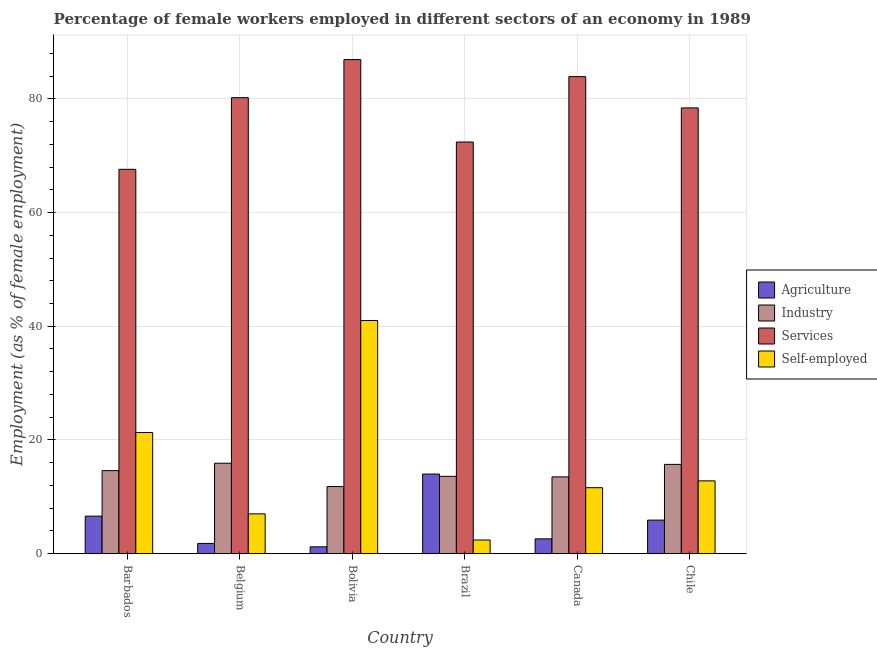How many different coloured bars are there?
Offer a terse response. 4. How many groups of bars are there?
Keep it short and to the point. 6. How many bars are there on the 1st tick from the right?
Offer a very short reply. 4. What is the percentage of female workers in industry in Brazil?
Offer a terse response. 13.6. Across all countries, what is the maximum percentage of female workers in services?
Give a very brief answer. 86.9. Across all countries, what is the minimum percentage of female workers in industry?
Your answer should be compact. 11.8. In which country was the percentage of self employed female workers minimum?
Provide a short and direct response. Brazil. What is the total percentage of self employed female workers in the graph?
Ensure brevity in your answer.  96.1. What is the difference between the percentage of female workers in agriculture in Barbados and that in Chile?
Provide a succinct answer. 0.7. What is the difference between the percentage of female workers in agriculture in Canada and the percentage of self employed female workers in Barbados?
Make the answer very short. -18.7. What is the average percentage of female workers in industry per country?
Give a very brief answer. 14.18. What is the difference between the percentage of female workers in services and percentage of female workers in industry in Chile?
Offer a very short reply. 62.7. What is the ratio of the percentage of female workers in industry in Bolivia to that in Brazil?
Your response must be concise. 0.87. Is the percentage of female workers in services in Belgium less than that in Canada?
Make the answer very short. Yes. Is the difference between the percentage of female workers in services in Belgium and Bolivia greater than the difference between the percentage of self employed female workers in Belgium and Bolivia?
Ensure brevity in your answer.  Yes. What is the difference between the highest and the second highest percentage of female workers in industry?
Your answer should be very brief. 0.2. What is the difference between the highest and the lowest percentage of self employed female workers?
Provide a succinct answer. 38.6. Is it the case that in every country, the sum of the percentage of female workers in services and percentage of female workers in industry is greater than the sum of percentage of female workers in agriculture and percentage of self employed female workers?
Keep it short and to the point. Yes. What does the 2nd bar from the left in Bolivia represents?
Give a very brief answer. Industry. What does the 4th bar from the right in Bolivia represents?
Offer a terse response. Agriculture. Is it the case that in every country, the sum of the percentage of female workers in agriculture and percentage of female workers in industry is greater than the percentage of female workers in services?
Your answer should be very brief. No. What is the difference between two consecutive major ticks on the Y-axis?
Ensure brevity in your answer.  20. Are the values on the major ticks of Y-axis written in scientific E-notation?
Your answer should be compact. No. Does the graph contain any zero values?
Ensure brevity in your answer.  No. Does the graph contain grids?
Ensure brevity in your answer.  Yes. What is the title of the graph?
Your answer should be very brief. Percentage of female workers employed in different sectors of an economy in 1989. Does "Italy" appear as one of the legend labels in the graph?
Your response must be concise. No. What is the label or title of the Y-axis?
Your answer should be compact. Employment (as % of female employment). What is the Employment (as % of female employment) of Agriculture in Barbados?
Keep it short and to the point. 6.6. What is the Employment (as % of female employment) of Industry in Barbados?
Your answer should be very brief. 14.6. What is the Employment (as % of female employment) in Services in Barbados?
Keep it short and to the point. 67.6. What is the Employment (as % of female employment) of Self-employed in Barbados?
Provide a succinct answer. 21.3. What is the Employment (as % of female employment) in Agriculture in Belgium?
Ensure brevity in your answer.  1.8. What is the Employment (as % of female employment) of Industry in Belgium?
Make the answer very short. 15.9. What is the Employment (as % of female employment) of Services in Belgium?
Give a very brief answer. 80.2. What is the Employment (as % of female employment) of Self-employed in Belgium?
Keep it short and to the point. 7. What is the Employment (as % of female employment) of Agriculture in Bolivia?
Your answer should be compact. 1.2. What is the Employment (as % of female employment) in Industry in Bolivia?
Your answer should be compact. 11.8. What is the Employment (as % of female employment) of Services in Bolivia?
Your answer should be compact. 86.9. What is the Employment (as % of female employment) of Industry in Brazil?
Provide a succinct answer. 13.6. What is the Employment (as % of female employment) of Services in Brazil?
Offer a terse response. 72.4. What is the Employment (as % of female employment) in Self-employed in Brazil?
Offer a terse response. 2.4. What is the Employment (as % of female employment) in Agriculture in Canada?
Offer a terse response. 2.6. What is the Employment (as % of female employment) of Industry in Canada?
Your response must be concise. 13.5. What is the Employment (as % of female employment) in Services in Canada?
Provide a short and direct response. 83.9. What is the Employment (as % of female employment) in Self-employed in Canada?
Give a very brief answer. 11.6. What is the Employment (as % of female employment) of Agriculture in Chile?
Provide a succinct answer. 5.9. What is the Employment (as % of female employment) of Industry in Chile?
Make the answer very short. 15.7. What is the Employment (as % of female employment) in Services in Chile?
Keep it short and to the point. 78.4. What is the Employment (as % of female employment) of Self-employed in Chile?
Provide a short and direct response. 12.8. Across all countries, what is the maximum Employment (as % of female employment) of Industry?
Provide a short and direct response. 15.9. Across all countries, what is the maximum Employment (as % of female employment) in Services?
Keep it short and to the point. 86.9. Across all countries, what is the minimum Employment (as % of female employment) of Agriculture?
Ensure brevity in your answer.  1.2. Across all countries, what is the minimum Employment (as % of female employment) in Industry?
Provide a short and direct response. 11.8. Across all countries, what is the minimum Employment (as % of female employment) of Services?
Give a very brief answer. 67.6. Across all countries, what is the minimum Employment (as % of female employment) in Self-employed?
Your response must be concise. 2.4. What is the total Employment (as % of female employment) in Agriculture in the graph?
Provide a short and direct response. 32.1. What is the total Employment (as % of female employment) of Industry in the graph?
Give a very brief answer. 85.1. What is the total Employment (as % of female employment) of Services in the graph?
Make the answer very short. 469.4. What is the total Employment (as % of female employment) in Self-employed in the graph?
Provide a short and direct response. 96.1. What is the difference between the Employment (as % of female employment) in Agriculture in Barbados and that in Belgium?
Offer a very short reply. 4.8. What is the difference between the Employment (as % of female employment) of Services in Barbados and that in Bolivia?
Provide a short and direct response. -19.3. What is the difference between the Employment (as % of female employment) of Self-employed in Barbados and that in Bolivia?
Your answer should be compact. -19.7. What is the difference between the Employment (as % of female employment) in Services in Barbados and that in Canada?
Offer a very short reply. -16.3. What is the difference between the Employment (as % of female employment) in Industry in Belgium and that in Bolivia?
Your answer should be very brief. 4.1. What is the difference between the Employment (as % of female employment) of Self-employed in Belgium and that in Bolivia?
Offer a terse response. -34. What is the difference between the Employment (as % of female employment) in Industry in Belgium and that in Canada?
Provide a succinct answer. 2.4. What is the difference between the Employment (as % of female employment) of Services in Belgium and that in Canada?
Provide a short and direct response. -3.7. What is the difference between the Employment (as % of female employment) in Agriculture in Belgium and that in Chile?
Offer a very short reply. -4.1. What is the difference between the Employment (as % of female employment) of Industry in Belgium and that in Chile?
Your answer should be very brief. 0.2. What is the difference between the Employment (as % of female employment) in Services in Belgium and that in Chile?
Offer a very short reply. 1.8. What is the difference between the Employment (as % of female employment) of Agriculture in Bolivia and that in Brazil?
Offer a very short reply. -12.8. What is the difference between the Employment (as % of female employment) of Industry in Bolivia and that in Brazil?
Give a very brief answer. -1.8. What is the difference between the Employment (as % of female employment) in Self-employed in Bolivia and that in Brazil?
Provide a succinct answer. 38.6. What is the difference between the Employment (as % of female employment) in Self-employed in Bolivia and that in Canada?
Offer a very short reply. 29.4. What is the difference between the Employment (as % of female employment) in Agriculture in Bolivia and that in Chile?
Make the answer very short. -4.7. What is the difference between the Employment (as % of female employment) of Industry in Bolivia and that in Chile?
Ensure brevity in your answer.  -3.9. What is the difference between the Employment (as % of female employment) in Services in Bolivia and that in Chile?
Ensure brevity in your answer.  8.5. What is the difference between the Employment (as % of female employment) in Self-employed in Bolivia and that in Chile?
Make the answer very short. 28.2. What is the difference between the Employment (as % of female employment) in Agriculture in Brazil and that in Canada?
Your response must be concise. 11.4. What is the difference between the Employment (as % of female employment) in Services in Brazil and that in Canada?
Keep it short and to the point. -11.5. What is the difference between the Employment (as % of female employment) in Services in Brazil and that in Chile?
Keep it short and to the point. -6. What is the difference between the Employment (as % of female employment) of Services in Canada and that in Chile?
Offer a very short reply. 5.5. What is the difference between the Employment (as % of female employment) in Agriculture in Barbados and the Employment (as % of female employment) in Industry in Belgium?
Your answer should be very brief. -9.3. What is the difference between the Employment (as % of female employment) of Agriculture in Barbados and the Employment (as % of female employment) of Services in Belgium?
Keep it short and to the point. -73.6. What is the difference between the Employment (as % of female employment) of Industry in Barbados and the Employment (as % of female employment) of Services in Belgium?
Offer a very short reply. -65.6. What is the difference between the Employment (as % of female employment) in Services in Barbados and the Employment (as % of female employment) in Self-employed in Belgium?
Keep it short and to the point. 60.6. What is the difference between the Employment (as % of female employment) of Agriculture in Barbados and the Employment (as % of female employment) of Industry in Bolivia?
Provide a short and direct response. -5.2. What is the difference between the Employment (as % of female employment) of Agriculture in Barbados and the Employment (as % of female employment) of Services in Bolivia?
Provide a short and direct response. -80.3. What is the difference between the Employment (as % of female employment) of Agriculture in Barbados and the Employment (as % of female employment) of Self-employed in Bolivia?
Your response must be concise. -34.4. What is the difference between the Employment (as % of female employment) in Industry in Barbados and the Employment (as % of female employment) in Services in Bolivia?
Keep it short and to the point. -72.3. What is the difference between the Employment (as % of female employment) of Industry in Barbados and the Employment (as % of female employment) of Self-employed in Bolivia?
Ensure brevity in your answer.  -26.4. What is the difference between the Employment (as % of female employment) of Services in Barbados and the Employment (as % of female employment) of Self-employed in Bolivia?
Offer a very short reply. 26.6. What is the difference between the Employment (as % of female employment) in Agriculture in Barbados and the Employment (as % of female employment) in Industry in Brazil?
Make the answer very short. -7. What is the difference between the Employment (as % of female employment) in Agriculture in Barbados and the Employment (as % of female employment) in Services in Brazil?
Keep it short and to the point. -65.8. What is the difference between the Employment (as % of female employment) in Agriculture in Barbados and the Employment (as % of female employment) in Self-employed in Brazil?
Offer a terse response. 4.2. What is the difference between the Employment (as % of female employment) in Industry in Barbados and the Employment (as % of female employment) in Services in Brazil?
Offer a terse response. -57.8. What is the difference between the Employment (as % of female employment) in Services in Barbados and the Employment (as % of female employment) in Self-employed in Brazil?
Give a very brief answer. 65.2. What is the difference between the Employment (as % of female employment) of Agriculture in Barbados and the Employment (as % of female employment) of Industry in Canada?
Make the answer very short. -6.9. What is the difference between the Employment (as % of female employment) in Agriculture in Barbados and the Employment (as % of female employment) in Services in Canada?
Give a very brief answer. -77.3. What is the difference between the Employment (as % of female employment) in Agriculture in Barbados and the Employment (as % of female employment) in Self-employed in Canada?
Ensure brevity in your answer.  -5. What is the difference between the Employment (as % of female employment) in Industry in Barbados and the Employment (as % of female employment) in Services in Canada?
Provide a short and direct response. -69.3. What is the difference between the Employment (as % of female employment) in Industry in Barbados and the Employment (as % of female employment) in Self-employed in Canada?
Provide a succinct answer. 3. What is the difference between the Employment (as % of female employment) in Agriculture in Barbados and the Employment (as % of female employment) in Industry in Chile?
Provide a succinct answer. -9.1. What is the difference between the Employment (as % of female employment) of Agriculture in Barbados and the Employment (as % of female employment) of Services in Chile?
Provide a short and direct response. -71.8. What is the difference between the Employment (as % of female employment) in Industry in Barbados and the Employment (as % of female employment) in Services in Chile?
Provide a succinct answer. -63.8. What is the difference between the Employment (as % of female employment) of Services in Barbados and the Employment (as % of female employment) of Self-employed in Chile?
Make the answer very short. 54.8. What is the difference between the Employment (as % of female employment) of Agriculture in Belgium and the Employment (as % of female employment) of Industry in Bolivia?
Keep it short and to the point. -10. What is the difference between the Employment (as % of female employment) of Agriculture in Belgium and the Employment (as % of female employment) of Services in Bolivia?
Your answer should be compact. -85.1. What is the difference between the Employment (as % of female employment) of Agriculture in Belgium and the Employment (as % of female employment) of Self-employed in Bolivia?
Offer a very short reply. -39.2. What is the difference between the Employment (as % of female employment) in Industry in Belgium and the Employment (as % of female employment) in Services in Bolivia?
Provide a succinct answer. -71. What is the difference between the Employment (as % of female employment) of Industry in Belgium and the Employment (as % of female employment) of Self-employed in Bolivia?
Give a very brief answer. -25.1. What is the difference between the Employment (as % of female employment) of Services in Belgium and the Employment (as % of female employment) of Self-employed in Bolivia?
Make the answer very short. 39.2. What is the difference between the Employment (as % of female employment) in Agriculture in Belgium and the Employment (as % of female employment) in Industry in Brazil?
Your response must be concise. -11.8. What is the difference between the Employment (as % of female employment) in Agriculture in Belgium and the Employment (as % of female employment) in Services in Brazil?
Provide a short and direct response. -70.6. What is the difference between the Employment (as % of female employment) in Industry in Belgium and the Employment (as % of female employment) in Services in Brazil?
Give a very brief answer. -56.5. What is the difference between the Employment (as % of female employment) of Services in Belgium and the Employment (as % of female employment) of Self-employed in Brazil?
Your answer should be very brief. 77.8. What is the difference between the Employment (as % of female employment) of Agriculture in Belgium and the Employment (as % of female employment) of Industry in Canada?
Make the answer very short. -11.7. What is the difference between the Employment (as % of female employment) in Agriculture in Belgium and the Employment (as % of female employment) in Services in Canada?
Offer a terse response. -82.1. What is the difference between the Employment (as % of female employment) of Agriculture in Belgium and the Employment (as % of female employment) of Self-employed in Canada?
Offer a very short reply. -9.8. What is the difference between the Employment (as % of female employment) of Industry in Belgium and the Employment (as % of female employment) of Services in Canada?
Offer a terse response. -68. What is the difference between the Employment (as % of female employment) of Services in Belgium and the Employment (as % of female employment) of Self-employed in Canada?
Provide a succinct answer. 68.6. What is the difference between the Employment (as % of female employment) of Agriculture in Belgium and the Employment (as % of female employment) of Industry in Chile?
Your answer should be very brief. -13.9. What is the difference between the Employment (as % of female employment) of Agriculture in Belgium and the Employment (as % of female employment) of Services in Chile?
Offer a terse response. -76.6. What is the difference between the Employment (as % of female employment) in Agriculture in Belgium and the Employment (as % of female employment) in Self-employed in Chile?
Provide a succinct answer. -11. What is the difference between the Employment (as % of female employment) in Industry in Belgium and the Employment (as % of female employment) in Services in Chile?
Your answer should be compact. -62.5. What is the difference between the Employment (as % of female employment) in Services in Belgium and the Employment (as % of female employment) in Self-employed in Chile?
Provide a short and direct response. 67.4. What is the difference between the Employment (as % of female employment) in Agriculture in Bolivia and the Employment (as % of female employment) in Services in Brazil?
Your answer should be compact. -71.2. What is the difference between the Employment (as % of female employment) of Industry in Bolivia and the Employment (as % of female employment) of Services in Brazil?
Your response must be concise. -60.6. What is the difference between the Employment (as % of female employment) in Industry in Bolivia and the Employment (as % of female employment) in Self-employed in Brazil?
Your response must be concise. 9.4. What is the difference between the Employment (as % of female employment) of Services in Bolivia and the Employment (as % of female employment) of Self-employed in Brazil?
Offer a very short reply. 84.5. What is the difference between the Employment (as % of female employment) of Agriculture in Bolivia and the Employment (as % of female employment) of Industry in Canada?
Ensure brevity in your answer.  -12.3. What is the difference between the Employment (as % of female employment) in Agriculture in Bolivia and the Employment (as % of female employment) in Services in Canada?
Your answer should be very brief. -82.7. What is the difference between the Employment (as % of female employment) of Industry in Bolivia and the Employment (as % of female employment) of Services in Canada?
Your answer should be compact. -72.1. What is the difference between the Employment (as % of female employment) of Services in Bolivia and the Employment (as % of female employment) of Self-employed in Canada?
Offer a very short reply. 75.3. What is the difference between the Employment (as % of female employment) of Agriculture in Bolivia and the Employment (as % of female employment) of Services in Chile?
Your response must be concise. -77.2. What is the difference between the Employment (as % of female employment) in Industry in Bolivia and the Employment (as % of female employment) in Services in Chile?
Your response must be concise. -66.6. What is the difference between the Employment (as % of female employment) in Industry in Bolivia and the Employment (as % of female employment) in Self-employed in Chile?
Make the answer very short. -1. What is the difference between the Employment (as % of female employment) of Services in Bolivia and the Employment (as % of female employment) of Self-employed in Chile?
Your response must be concise. 74.1. What is the difference between the Employment (as % of female employment) of Agriculture in Brazil and the Employment (as % of female employment) of Industry in Canada?
Your response must be concise. 0.5. What is the difference between the Employment (as % of female employment) of Agriculture in Brazil and the Employment (as % of female employment) of Services in Canada?
Offer a terse response. -69.9. What is the difference between the Employment (as % of female employment) in Agriculture in Brazil and the Employment (as % of female employment) in Self-employed in Canada?
Your response must be concise. 2.4. What is the difference between the Employment (as % of female employment) in Industry in Brazil and the Employment (as % of female employment) in Services in Canada?
Ensure brevity in your answer.  -70.3. What is the difference between the Employment (as % of female employment) of Industry in Brazil and the Employment (as % of female employment) of Self-employed in Canada?
Provide a succinct answer. 2. What is the difference between the Employment (as % of female employment) of Services in Brazil and the Employment (as % of female employment) of Self-employed in Canada?
Keep it short and to the point. 60.8. What is the difference between the Employment (as % of female employment) of Agriculture in Brazil and the Employment (as % of female employment) of Services in Chile?
Make the answer very short. -64.4. What is the difference between the Employment (as % of female employment) of Agriculture in Brazil and the Employment (as % of female employment) of Self-employed in Chile?
Provide a short and direct response. 1.2. What is the difference between the Employment (as % of female employment) of Industry in Brazil and the Employment (as % of female employment) of Services in Chile?
Offer a very short reply. -64.8. What is the difference between the Employment (as % of female employment) in Services in Brazil and the Employment (as % of female employment) in Self-employed in Chile?
Make the answer very short. 59.6. What is the difference between the Employment (as % of female employment) of Agriculture in Canada and the Employment (as % of female employment) of Services in Chile?
Provide a short and direct response. -75.8. What is the difference between the Employment (as % of female employment) of Industry in Canada and the Employment (as % of female employment) of Services in Chile?
Offer a terse response. -64.9. What is the difference between the Employment (as % of female employment) in Industry in Canada and the Employment (as % of female employment) in Self-employed in Chile?
Your response must be concise. 0.7. What is the difference between the Employment (as % of female employment) in Services in Canada and the Employment (as % of female employment) in Self-employed in Chile?
Offer a terse response. 71.1. What is the average Employment (as % of female employment) in Agriculture per country?
Provide a short and direct response. 5.35. What is the average Employment (as % of female employment) of Industry per country?
Keep it short and to the point. 14.18. What is the average Employment (as % of female employment) of Services per country?
Your response must be concise. 78.23. What is the average Employment (as % of female employment) in Self-employed per country?
Keep it short and to the point. 16.02. What is the difference between the Employment (as % of female employment) of Agriculture and Employment (as % of female employment) of Industry in Barbados?
Your answer should be very brief. -8. What is the difference between the Employment (as % of female employment) of Agriculture and Employment (as % of female employment) of Services in Barbados?
Make the answer very short. -61. What is the difference between the Employment (as % of female employment) of Agriculture and Employment (as % of female employment) of Self-employed in Barbados?
Ensure brevity in your answer.  -14.7. What is the difference between the Employment (as % of female employment) in Industry and Employment (as % of female employment) in Services in Barbados?
Give a very brief answer. -53. What is the difference between the Employment (as % of female employment) of Services and Employment (as % of female employment) of Self-employed in Barbados?
Provide a succinct answer. 46.3. What is the difference between the Employment (as % of female employment) of Agriculture and Employment (as % of female employment) of Industry in Belgium?
Provide a short and direct response. -14.1. What is the difference between the Employment (as % of female employment) in Agriculture and Employment (as % of female employment) in Services in Belgium?
Ensure brevity in your answer.  -78.4. What is the difference between the Employment (as % of female employment) in Agriculture and Employment (as % of female employment) in Self-employed in Belgium?
Provide a short and direct response. -5.2. What is the difference between the Employment (as % of female employment) in Industry and Employment (as % of female employment) in Services in Belgium?
Offer a very short reply. -64.3. What is the difference between the Employment (as % of female employment) of Services and Employment (as % of female employment) of Self-employed in Belgium?
Offer a very short reply. 73.2. What is the difference between the Employment (as % of female employment) in Agriculture and Employment (as % of female employment) in Services in Bolivia?
Provide a short and direct response. -85.7. What is the difference between the Employment (as % of female employment) in Agriculture and Employment (as % of female employment) in Self-employed in Bolivia?
Give a very brief answer. -39.8. What is the difference between the Employment (as % of female employment) in Industry and Employment (as % of female employment) in Services in Bolivia?
Your response must be concise. -75.1. What is the difference between the Employment (as % of female employment) in Industry and Employment (as % of female employment) in Self-employed in Bolivia?
Make the answer very short. -29.2. What is the difference between the Employment (as % of female employment) in Services and Employment (as % of female employment) in Self-employed in Bolivia?
Ensure brevity in your answer.  45.9. What is the difference between the Employment (as % of female employment) in Agriculture and Employment (as % of female employment) in Services in Brazil?
Your response must be concise. -58.4. What is the difference between the Employment (as % of female employment) of Industry and Employment (as % of female employment) of Services in Brazil?
Your response must be concise. -58.8. What is the difference between the Employment (as % of female employment) in Agriculture and Employment (as % of female employment) in Industry in Canada?
Give a very brief answer. -10.9. What is the difference between the Employment (as % of female employment) of Agriculture and Employment (as % of female employment) of Services in Canada?
Provide a short and direct response. -81.3. What is the difference between the Employment (as % of female employment) of Agriculture and Employment (as % of female employment) of Self-employed in Canada?
Offer a very short reply. -9. What is the difference between the Employment (as % of female employment) of Industry and Employment (as % of female employment) of Services in Canada?
Provide a succinct answer. -70.4. What is the difference between the Employment (as % of female employment) in Industry and Employment (as % of female employment) in Self-employed in Canada?
Your response must be concise. 1.9. What is the difference between the Employment (as % of female employment) in Services and Employment (as % of female employment) in Self-employed in Canada?
Your answer should be compact. 72.3. What is the difference between the Employment (as % of female employment) of Agriculture and Employment (as % of female employment) of Industry in Chile?
Your answer should be compact. -9.8. What is the difference between the Employment (as % of female employment) in Agriculture and Employment (as % of female employment) in Services in Chile?
Provide a succinct answer. -72.5. What is the difference between the Employment (as % of female employment) of Agriculture and Employment (as % of female employment) of Self-employed in Chile?
Give a very brief answer. -6.9. What is the difference between the Employment (as % of female employment) of Industry and Employment (as % of female employment) of Services in Chile?
Make the answer very short. -62.7. What is the difference between the Employment (as % of female employment) of Services and Employment (as % of female employment) of Self-employed in Chile?
Your answer should be very brief. 65.6. What is the ratio of the Employment (as % of female employment) of Agriculture in Barbados to that in Belgium?
Ensure brevity in your answer.  3.67. What is the ratio of the Employment (as % of female employment) of Industry in Barbados to that in Belgium?
Offer a terse response. 0.92. What is the ratio of the Employment (as % of female employment) of Services in Barbados to that in Belgium?
Offer a terse response. 0.84. What is the ratio of the Employment (as % of female employment) in Self-employed in Barbados to that in Belgium?
Give a very brief answer. 3.04. What is the ratio of the Employment (as % of female employment) in Industry in Barbados to that in Bolivia?
Provide a short and direct response. 1.24. What is the ratio of the Employment (as % of female employment) of Services in Barbados to that in Bolivia?
Your response must be concise. 0.78. What is the ratio of the Employment (as % of female employment) of Self-employed in Barbados to that in Bolivia?
Offer a terse response. 0.52. What is the ratio of the Employment (as % of female employment) of Agriculture in Barbados to that in Brazil?
Offer a terse response. 0.47. What is the ratio of the Employment (as % of female employment) of Industry in Barbados to that in Brazil?
Your answer should be compact. 1.07. What is the ratio of the Employment (as % of female employment) in Services in Barbados to that in Brazil?
Your answer should be very brief. 0.93. What is the ratio of the Employment (as % of female employment) in Self-employed in Barbados to that in Brazil?
Your answer should be very brief. 8.88. What is the ratio of the Employment (as % of female employment) in Agriculture in Barbados to that in Canada?
Provide a short and direct response. 2.54. What is the ratio of the Employment (as % of female employment) in Industry in Barbados to that in Canada?
Your response must be concise. 1.08. What is the ratio of the Employment (as % of female employment) in Services in Barbados to that in Canada?
Provide a succinct answer. 0.81. What is the ratio of the Employment (as % of female employment) of Self-employed in Barbados to that in Canada?
Your answer should be compact. 1.84. What is the ratio of the Employment (as % of female employment) in Agriculture in Barbados to that in Chile?
Your response must be concise. 1.12. What is the ratio of the Employment (as % of female employment) of Industry in Barbados to that in Chile?
Keep it short and to the point. 0.93. What is the ratio of the Employment (as % of female employment) in Services in Barbados to that in Chile?
Make the answer very short. 0.86. What is the ratio of the Employment (as % of female employment) in Self-employed in Barbados to that in Chile?
Provide a succinct answer. 1.66. What is the ratio of the Employment (as % of female employment) in Industry in Belgium to that in Bolivia?
Your answer should be compact. 1.35. What is the ratio of the Employment (as % of female employment) in Services in Belgium to that in Bolivia?
Ensure brevity in your answer.  0.92. What is the ratio of the Employment (as % of female employment) of Self-employed in Belgium to that in Bolivia?
Your response must be concise. 0.17. What is the ratio of the Employment (as % of female employment) of Agriculture in Belgium to that in Brazil?
Offer a very short reply. 0.13. What is the ratio of the Employment (as % of female employment) of Industry in Belgium to that in Brazil?
Give a very brief answer. 1.17. What is the ratio of the Employment (as % of female employment) in Services in Belgium to that in Brazil?
Your answer should be compact. 1.11. What is the ratio of the Employment (as % of female employment) of Self-employed in Belgium to that in Brazil?
Give a very brief answer. 2.92. What is the ratio of the Employment (as % of female employment) of Agriculture in Belgium to that in Canada?
Provide a short and direct response. 0.69. What is the ratio of the Employment (as % of female employment) in Industry in Belgium to that in Canada?
Offer a very short reply. 1.18. What is the ratio of the Employment (as % of female employment) of Services in Belgium to that in Canada?
Provide a short and direct response. 0.96. What is the ratio of the Employment (as % of female employment) of Self-employed in Belgium to that in Canada?
Provide a short and direct response. 0.6. What is the ratio of the Employment (as % of female employment) in Agriculture in Belgium to that in Chile?
Ensure brevity in your answer.  0.31. What is the ratio of the Employment (as % of female employment) of Industry in Belgium to that in Chile?
Offer a very short reply. 1.01. What is the ratio of the Employment (as % of female employment) of Services in Belgium to that in Chile?
Offer a very short reply. 1.02. What is the ratio of the Employment (as % of female employment) in Self-employed in Belgium to that in Chile?
Ensure brevity in your answer.  0.55. What is the ratio of the Employment (as % of female employment) of Agriculture in Bolivia to that in Brazil?
Your answer should be compact. 0.09. What is the ratio of the Employment (as % of female employment) of Industry in Bolivia to that in Brazil?
Provide a short and direct response. 0.87. What is the ratio of the Employment (as % of female employment) of Services in Bolivia to that in Brazil?
Your answer should be compact. 1.2. What is the ratio of the Employment (as % of female employment) of Self-employed in Bolivia to that in Brazil?
Offer a very short reply. 17.08. What is the ratio of the Employment (as % of female employment) in Agriculture in Bolivia to that in Canada?
Ensure brevity in your answer.  0.46. What is the ratio of the Employment (as % of female employment) in Industry in Bolivia to that in Canada?
Provide a short and direct response. 0.87. What is the ratio of the Employment (as % of female employment) in Services in Bolivia to that in Canada?
Make the answer very short. 1.04. What is the ratio of the Employment (as % of female employment) of Self-employed in Bolivia to that in Canada?
Offer a terse response. 3.53. What is the ratio of the Employment (as % of female employment) in Agriculture in Bolivia to that in Chile?
Ensure brevity in your answer.  0.2. What is the ratio of the Employment (as % of female employment) in Industry in Bolivia to that in Chile?
Offer a terse response. 0.75. What is the ratio of the Employment (as % of female employment) of Services in Bolivia to that in Chile?
Provide a succinct answer. 1.11. What is the ratio of the Employment (as % of female employment) of Self-employed in Bolivia to that in Chile?
Make the answer very short. 3.2. What is the ratio of the Employment (as % of female employment) of Agriculture in Brazil to that in Canada?
Make the answer very short. 5.38. What is the ratio of the Employment (as % of female employment) of Industry in Brazil to that in Canada?
Your response must be concise. 1.01. What is the ratio of the Employment (as % of female employment) of Services in Brazil to that in Canada?
Your response must be concise. 0.86. What is the ratio of the Employment (as % of female employment) in Self-employed in Brazil to that in Canada?
Your response must be concise. 0.21. What is the ratio of the Employment (as % of female employment) of Agriculture in Brazil to that in Chile?
Keep it short and to the point. 2.37. What is the ratio of the Employment (as % of female employment) in Industry in Brazil to that in Chile?
Provide a short and direct response. 0.87. What is the ratio of the Employment (as % of female employment) of Services in Brazil to that in Chile?
Your answer should be compact. 0.92. What is the ratio of the Employment (as % of female employment) of Self-employed in Brazil to that in Chile?
Your answer should be very brief. 0.19. What is the ratio of the Employment (as % of female employment) of Agriculture in Canada to that in Chile?
Offer a very short reply. 0.44. What is the ratio of the Employment (as % of female employment) of Industry in Canada to that in Chile?
Ensure brevity in your answer.  0.86. What is the ratio of the Employment (as % of female employment) in Services in Canada to that in Chile?
Give a very brief answer. 1.07. What is the ratio of the Employment (as % of female employment) of Self-employed in Canada to that in Chile?
Your answer should be compact. 0.91. What is the difference between the highest and the second highest Employment (as % of female employment) of Agriculture?
Make the answer very short. 7.4. What is the difference between the highest and the second highest Employment (as % of female employment) in Industry?
Provide a short and direct response. 0.2. What is the difference between the highest and the second highest Employment (as % of female employment) of Services?
Provide a short and direct response. 3. What is the difference between the highest and the lowest Employment (as % of female employment) of Services?
Your response must be concise. 19.3. What is the difference between the highest and the lowest Employment (as % of female employment) in Self-employed?
Ensure brevity in your answer.  38.6. 